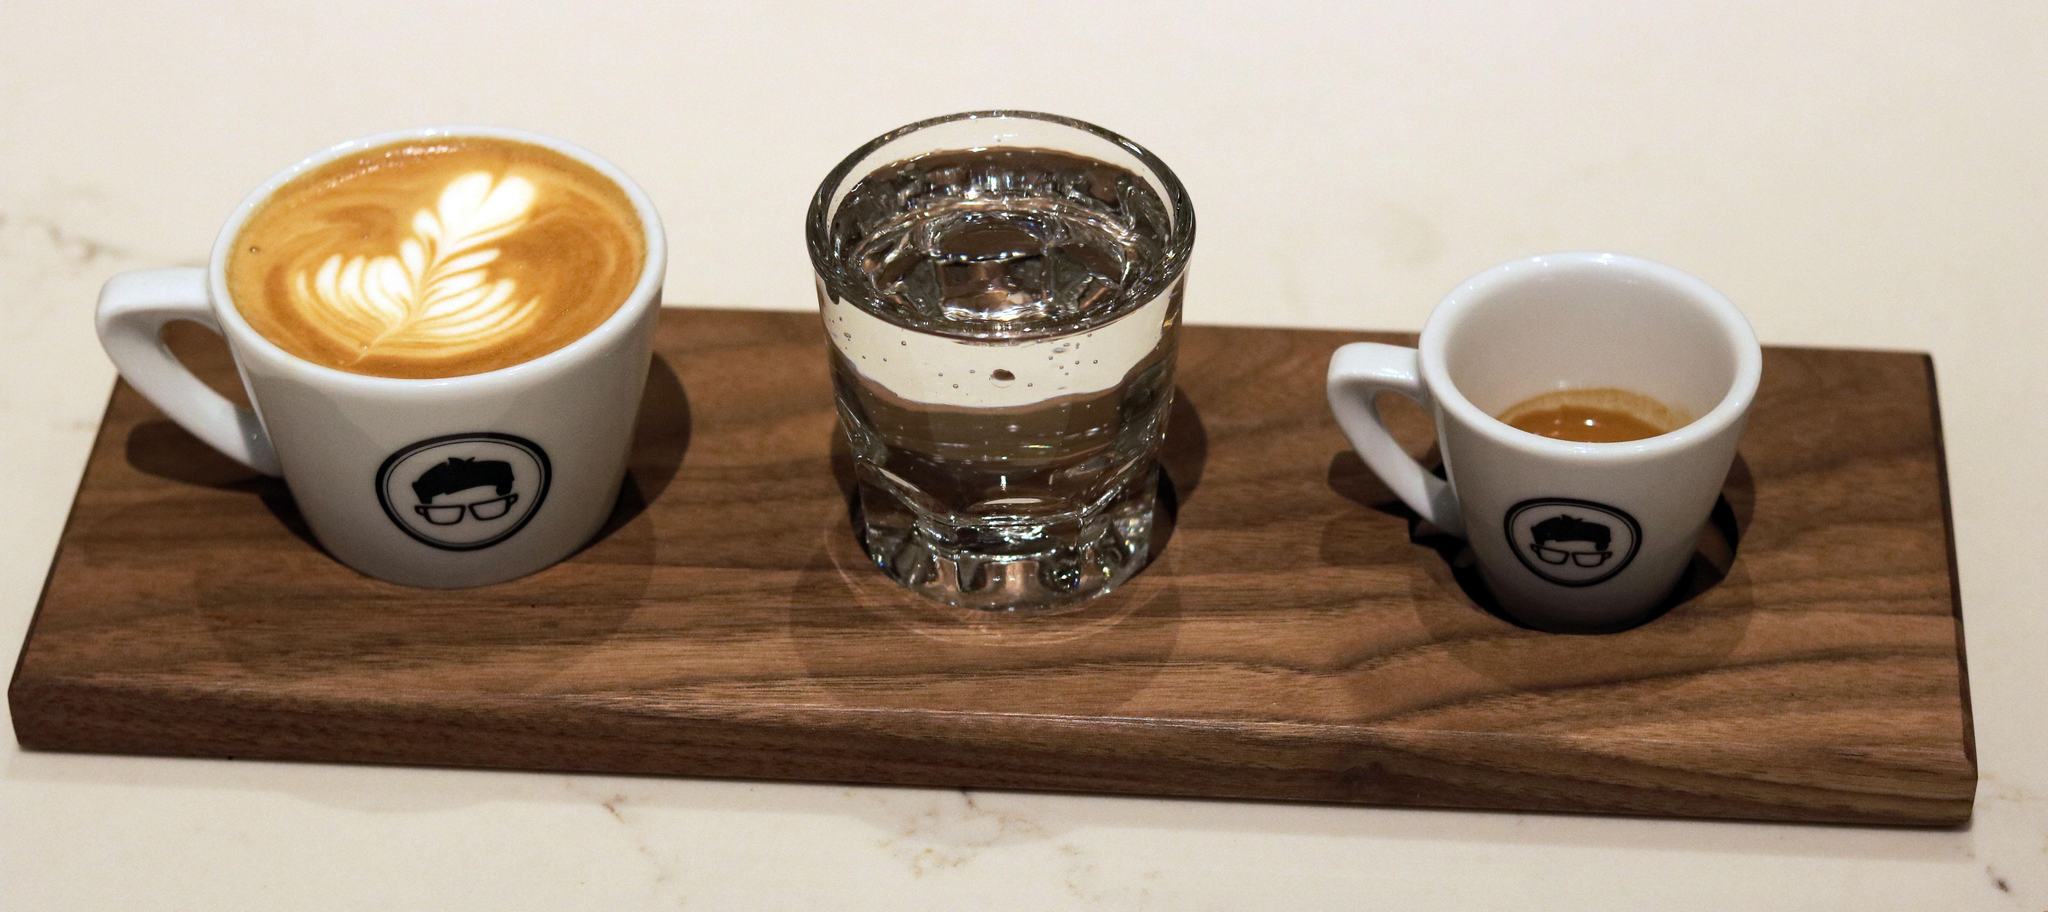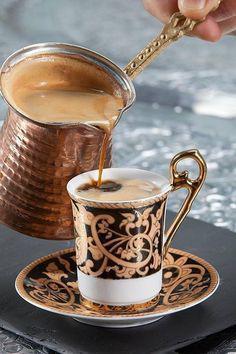The first image is the image on the left, the second image is the image on the right. Examine the images to the left and right. Is the description "Each image shows two matching hot drinks in cups, one of the pairs, cups of coffee with heart shaped froth designs." accurate? Answer yes or no. No. 